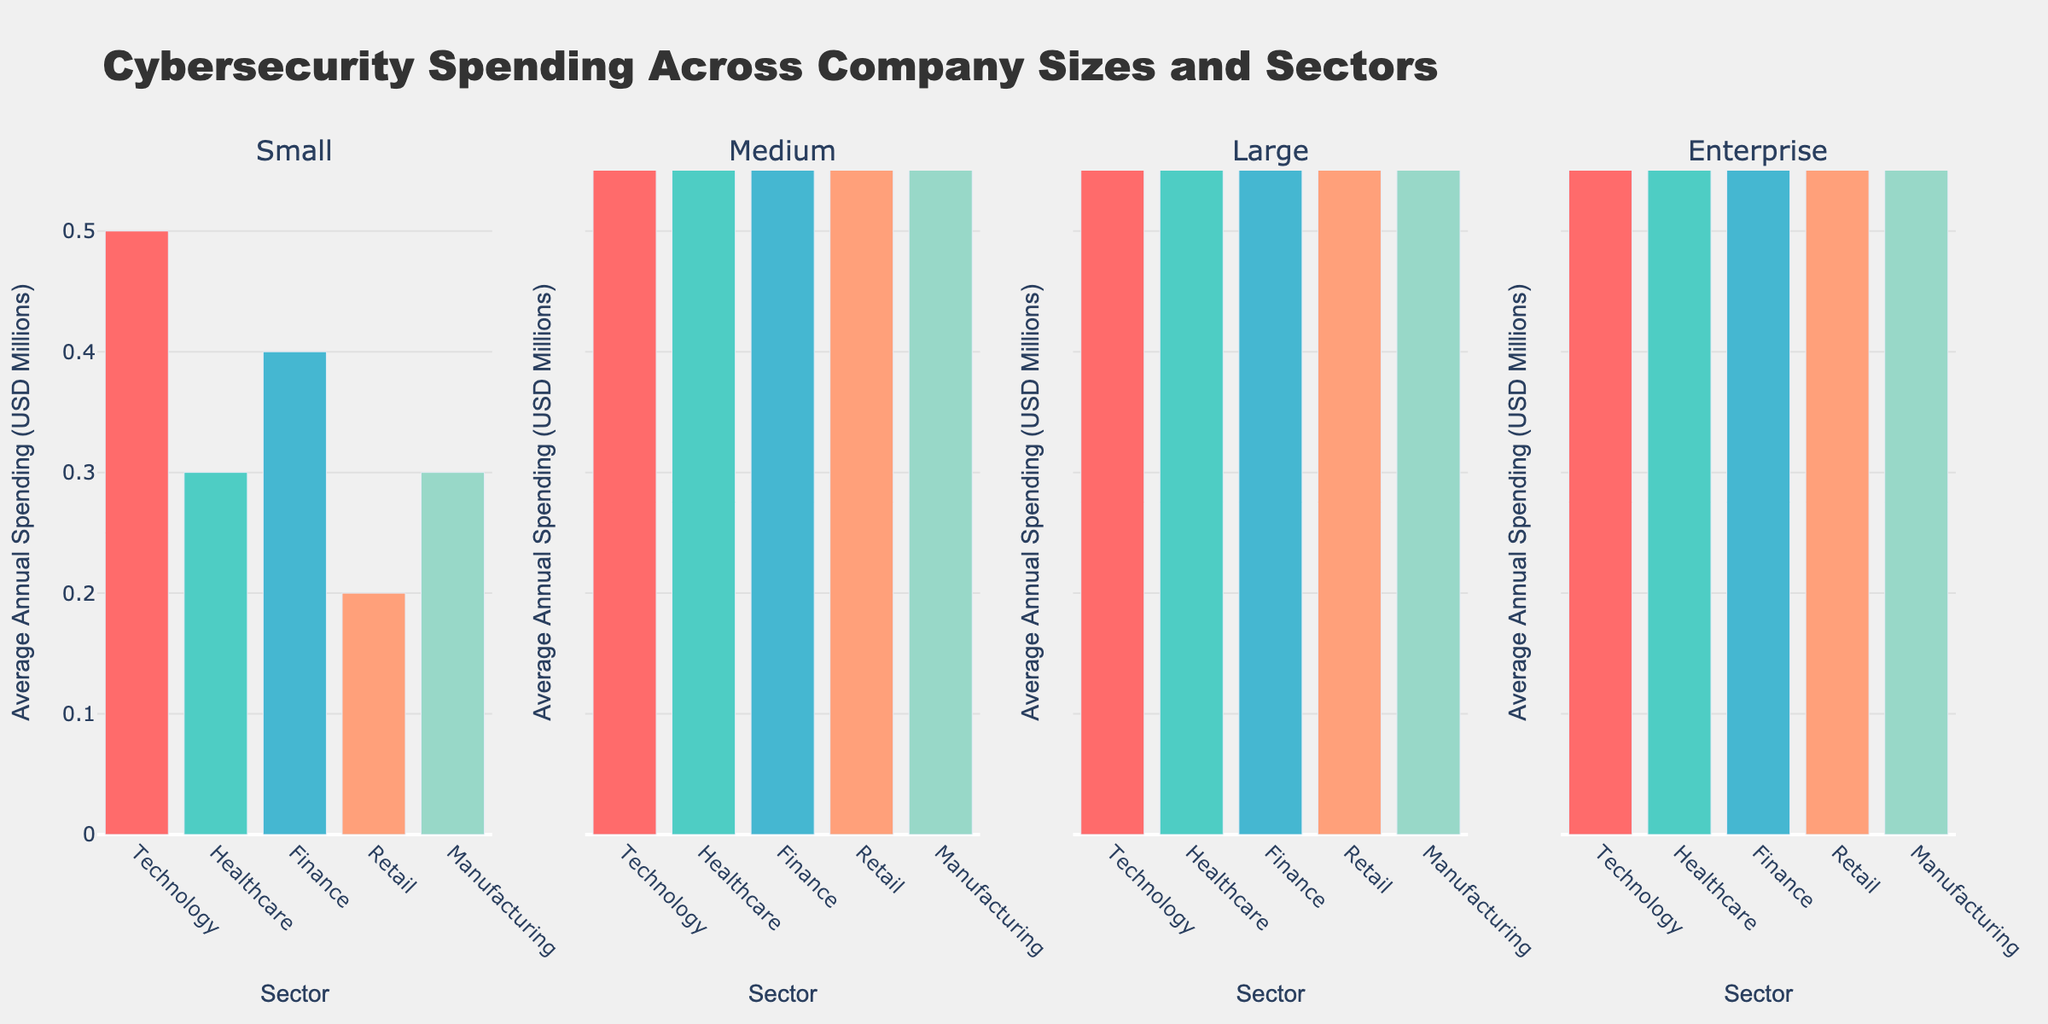Which sector has the highest average annual cybersecurity spending for large companies? To determine the sector with the highest spending for large companies, we look at all the bars in the 'Large' company size subplot and identify the tallest one. The tallest bar is in the Finance sector, which indicates the highest spending.
Answer: Finance How much more do enterprise companies in the finance sector spend on cybersecurity compared to small companies in the same sector? Find the bar height for enterprise companies in the finance sector (60 million USD) and small companies in the same sector (0.4 million USD). Then, subtract the small company spending from the enterprise company spending: 60 - 0.4 = 59.6 million USD.
Answer: 59.6 million USD Which sector has the smallest difference in average annual cybersecurity spending between small and large companies? For each sector, calculate the difference in spending between small and large companies. In the Technology sector, the difference is 15 - 0.5 = 14.5 million USD; in Healthcare, it is 12 - 0.3 = 11.7 million USD; in Finance, it is 18 - 0.4 = 17.6 million USD; in Retail, it is 8 - 0.2 = 7.8 million USD; and in Manufacturing, it is 10 - 0.3 = 9.7 million USD. The smallest difference is in the Retail sector with 7.8 million USD.
Answer: Retail Which company size spends the least on cybersecurity in the retail sector? Identify the smallest bar in the Retail sector across all company size subplots. The smallest bar in the Retail sector is for small companies, with a spending of 0.2 million USD.
Answer: Small What is the average annual cybersecurity spending for medium-sized companies across all sectors? For medium-sized companies, sum up the spending in each sector: 2.5 (Technology) + 2.0 (Healthcare) + 2.8 (Finance) + 1.5 (Retail) + 1.8 (Manufacturing) = 10.6. Then, divide by the number of sectors (5): 10.6 / 5 = 2.12 million USD.
Answer: 2.12 million USD In which sector is the ratio of enterprise to small company cybersecurity spending the highest? For each sector, calculate the ratio of enterprise spending to small company spending: Technology: 50 / 0.5 = 100; Healthcare: 40 / 0.3 ≈ 133.33; Finance: 60 / 0.4 = 150; Retail: 30 / 0.2 = 150; Manufacturing: 35 / 0.3 ≈ 116.67. The highest ratio is in both Finance and Retail sectors, each with a ratio of 150.
Answer: Finance and Retail What's the total cybersecurity spending for large companies across all sectors? Add the average annual spending for large companies in each sector: 15 (Technology) + 12 (Healthcare) + 18 (Finance) + 8 (Retail) + 10 (Manufacturing) = 63 million USD.
Answer: 63 million USD Which company size has the most variation in cybersecurity spending across different sectors? Compare the range (maximum - minimum) of spending for each company size: Small: 0.5 - 0.2 = 0.3; Medium: 2.8 - 1.5 = 1.3; Large: 18 - 8 = 10; Enterprise: 60 - 30 = 30. The enterprise companies have the most variation.
Answer: Enterprise Which sector shows the least difference between medium and large company spending? Calculate the difference for each sector: Technology: 15 - 2.5 = 12.5; Healthcare: 12 - 2 = 10; Finance: 18 - 2.8 = 15.2; Retail: 8 - 1.5 = 6.5; Manufacturing: 10 - 1.8 = 8.2. The Retail sector has the smallest difference with 6.5 million USD.
Answer: Retail 